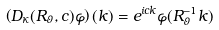<formula> <loc_0><loc_0><loc_500><loc_500>\left ( D _ { \kappa } ( R _ { \vartheta } , c ) \varphi \right ) ( k ) = e ^ { i c k } \varphi ( R _ { \vartheta } ^ { - 1 } k )</formula> 